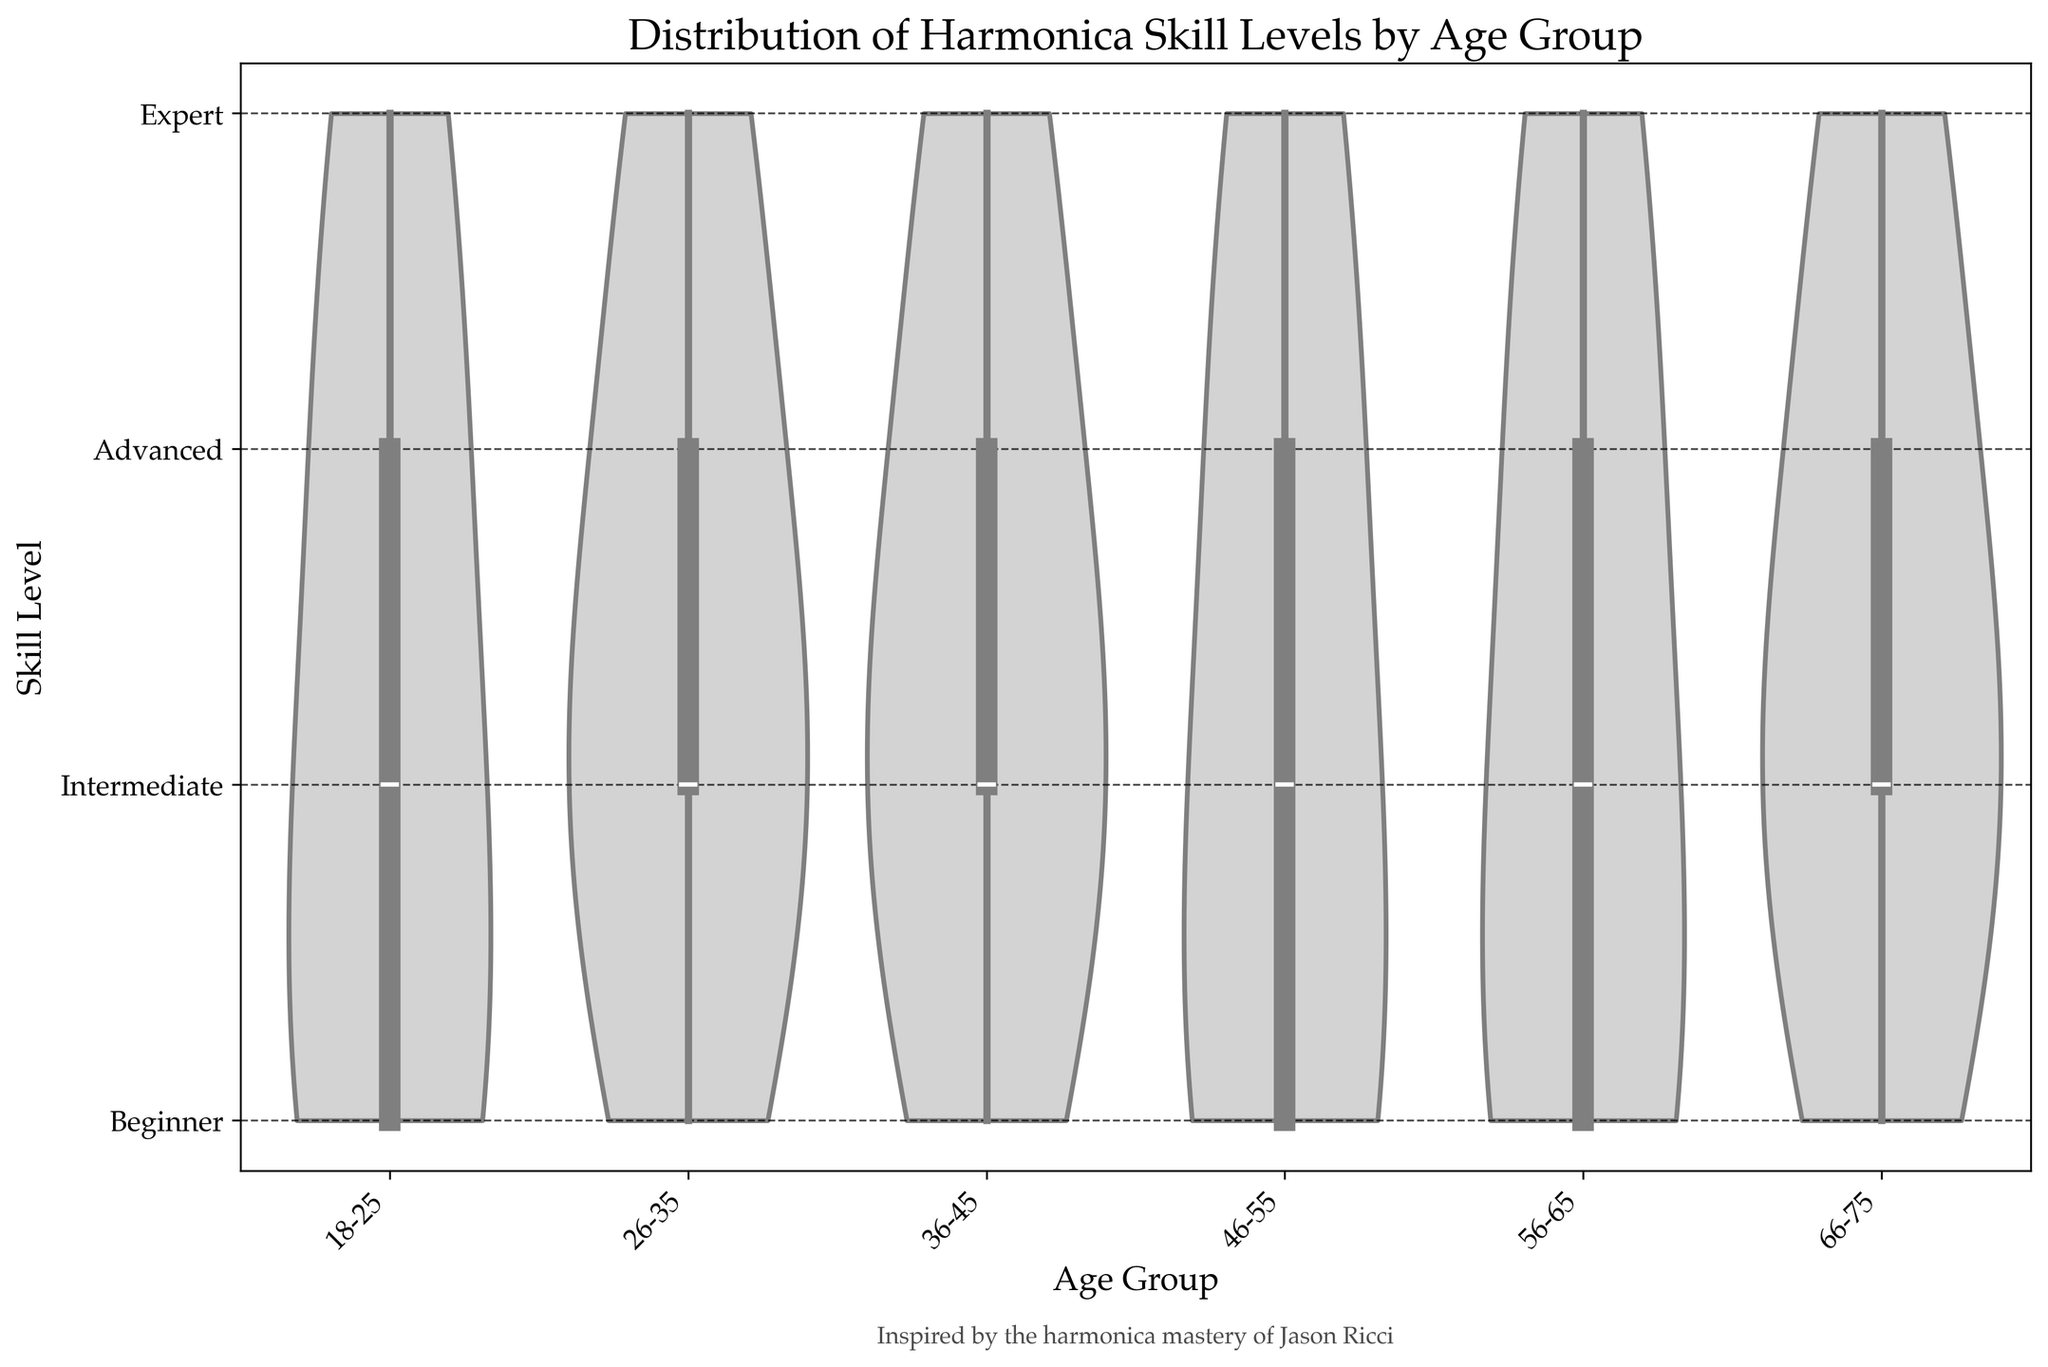What is the title of the figure? The title is usually located at the top of the figure. In this case, it reads 'Distribution of Harmonica Skill Levels by Age Group'.
Answer: Distribution of Harmonica Skill Levels by Age Group What does the y-axis represent in this figure? The y-axis indicates the harmonica skill levels, labeled from 'Beginner' at 1 to 'Expert' at 4.
Answer: Harmonica skill levels Which age group shows the widest spread of harmonica skill levels? The width of the violin plot signifies the distribution; the 36-45 age group shows a wide spread across all skill levels from Beginner to Expert.
Answer: 36-45 What is the most common skill level for the 18-25 age group? The thickest part of the violin plot for 18-25 is at the 'Beginner' level, indicating it is the most common skill level in this age group.
Answer: Beginner Are there any age groups where 'Expert' is the most common skill level? To determine this, check the thickness at the 'Expert' level across age groups. No age group has 'Expert' as the thickest part of its violin plot.
Answer: No Comparing 26-35 and 46-55 age groups, which is more evenly distributed across all skill levels? The 26-35 age group's violin plot has relatively even width across all skill levels compared to the 46-55 age group, indicating a more even distribution.
Answer: 26-35 What is the median skill level for the 56-65 age group? The median is indicated by the line in the box plot within the violin plot. For the 56-65 age group, this line is at the 'Intermediate' level.
Answer: Intermediate Which age group has the highest density of 'Advanced' level players? The widest part at the 'Advanced' level of the violin plots shows the density; the 36-45 age group has the highest density at this level.
Answer: 36-45 Is there any age group where 'Beginner' is the least common skill level? Look for the least width at the 'Beginner' level in the violin plots; the 66-75 age group shows a smaller width at 'Beginner' compared to other skill levels.
Answer: 66-75 